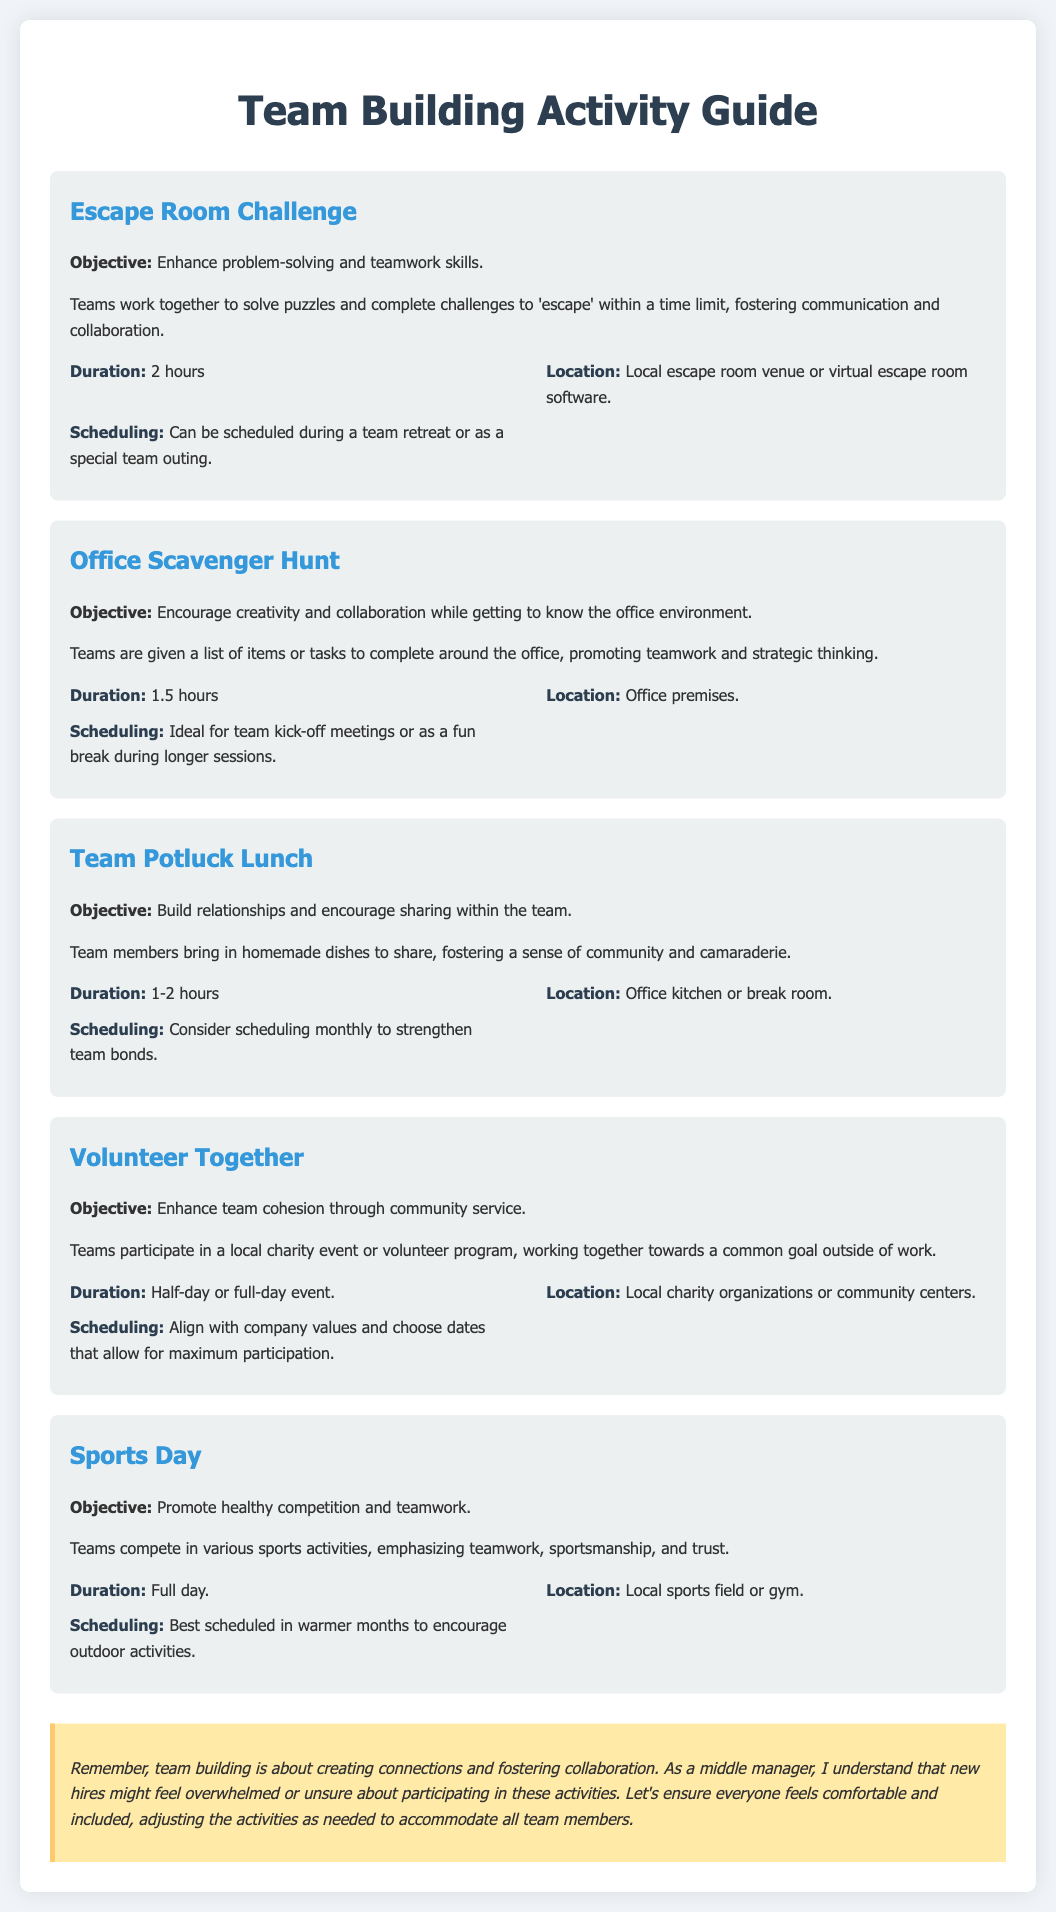What is the objective of the Escape Room Challenge? The objective of the Escape Room Challenge is to enhance problem-solving and teamwork skills.
Answer: Enhance problem-solving and teamwork skills How long does the Office Scavenger Hunt last? The document states the duration of the Office Scavenger Hunt is 1.5 hours.
Answer: 1.5 hours Where can the Team Potluck Lunch be held? The location for the Team Potluck Lunch is specified as the office kitchen or break room.
Answer: Office kitchen or break room What type of event is Volunteer Together? The Volunteer Together activity is a community service event.
Answer: Community service event When is Sports Day best scheduled? The document suggests that Sports Day is best scheduled in warmer months.
Answer: Warmer months What is a suggested frequency for the Team Potluck Lunch? The document recommends scheduling the Team Potluck Lunch monthly to strengthen team bonds.
Answer: Monthly What does the empathy note emphasize? The empathy note emphasizes that team building is about creating connections and fostering collaboration.
Answer: Creating connections and fostering collaboration What is a common goal shared in the Volunteer Together activity? The common goal in the Volunteer Together activity is working together towards a common goal outside of work.
Answer: Common goal outside of work What is the main purpose of the Office Scavenger Hunt? The main purpose of the Office Scavenger Hunt is to encourage creativity and collaboration while getting to know the office environment.
Answer: Encourage creativity and collaboration 